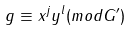<formula> <loc_0><loc_0><loc_500><loc_500>g \equiv x ^ { j } y ^ { l } ( m o d G ^ { \prime } )</formula> 